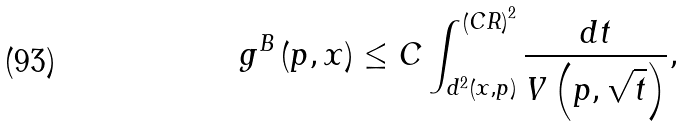<formula> <loc_0><loc_0><loc_500><loc_500>g ^ { B } \left ( p , x \right ) \leq C \int _ { d ^ { 2 } \left ( x , p \right ) } ^ { \left ( C R \right ) ^ { 2 } } \frac { d t } { V \left ( p , \sqrt { t } \right ) } ,</formula> 